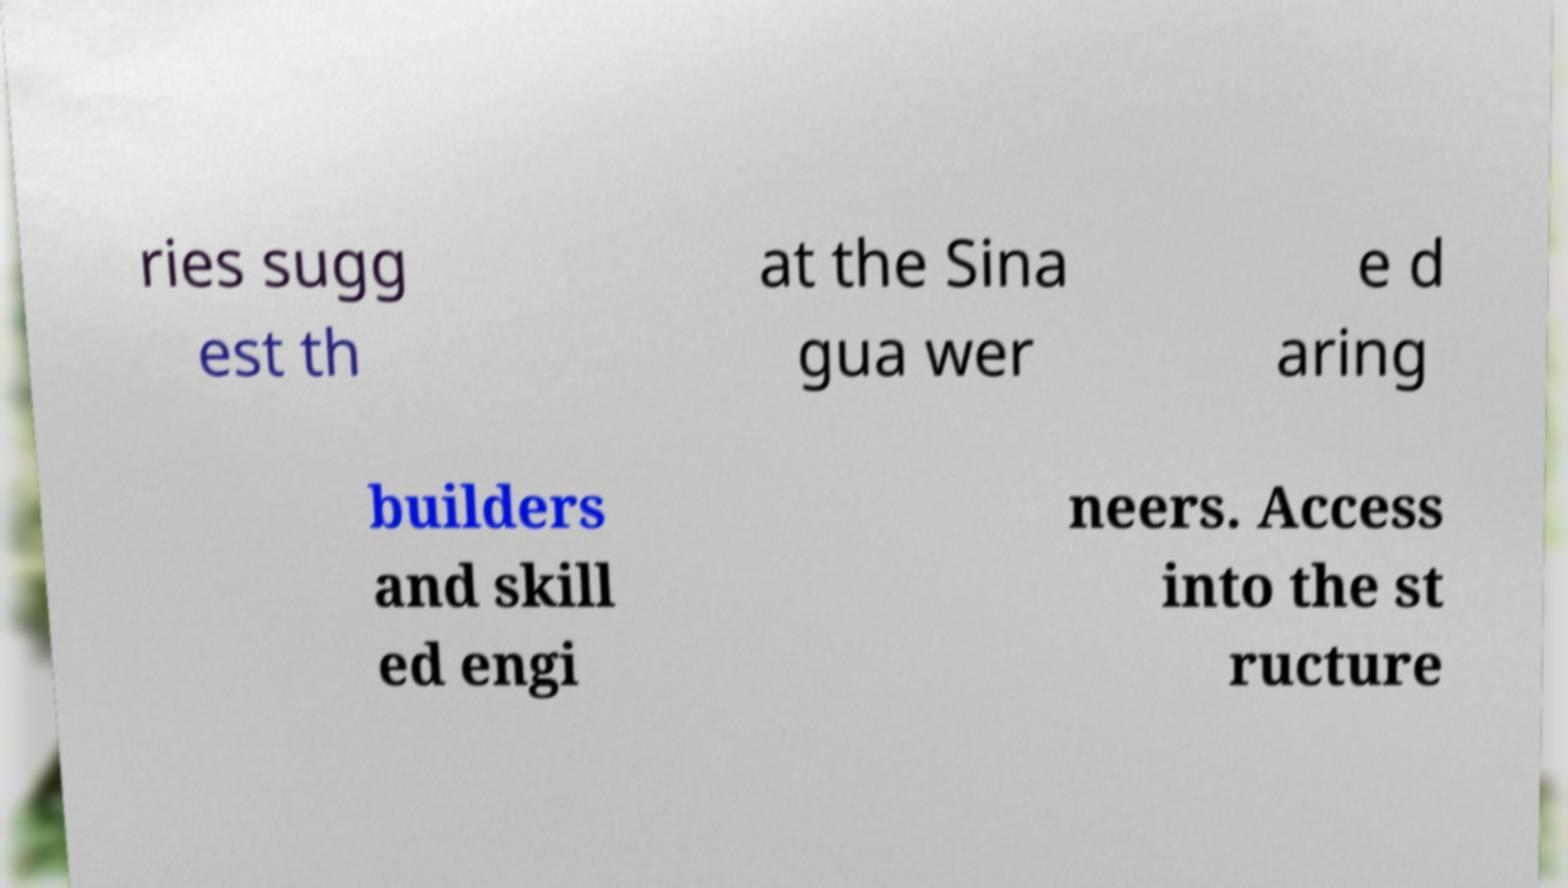Please read and relay the text visible in this image. What does it say? ries sugg est th at the Sina gua wer e d aring builders and skill ed engi neers. Access into the st ructure 